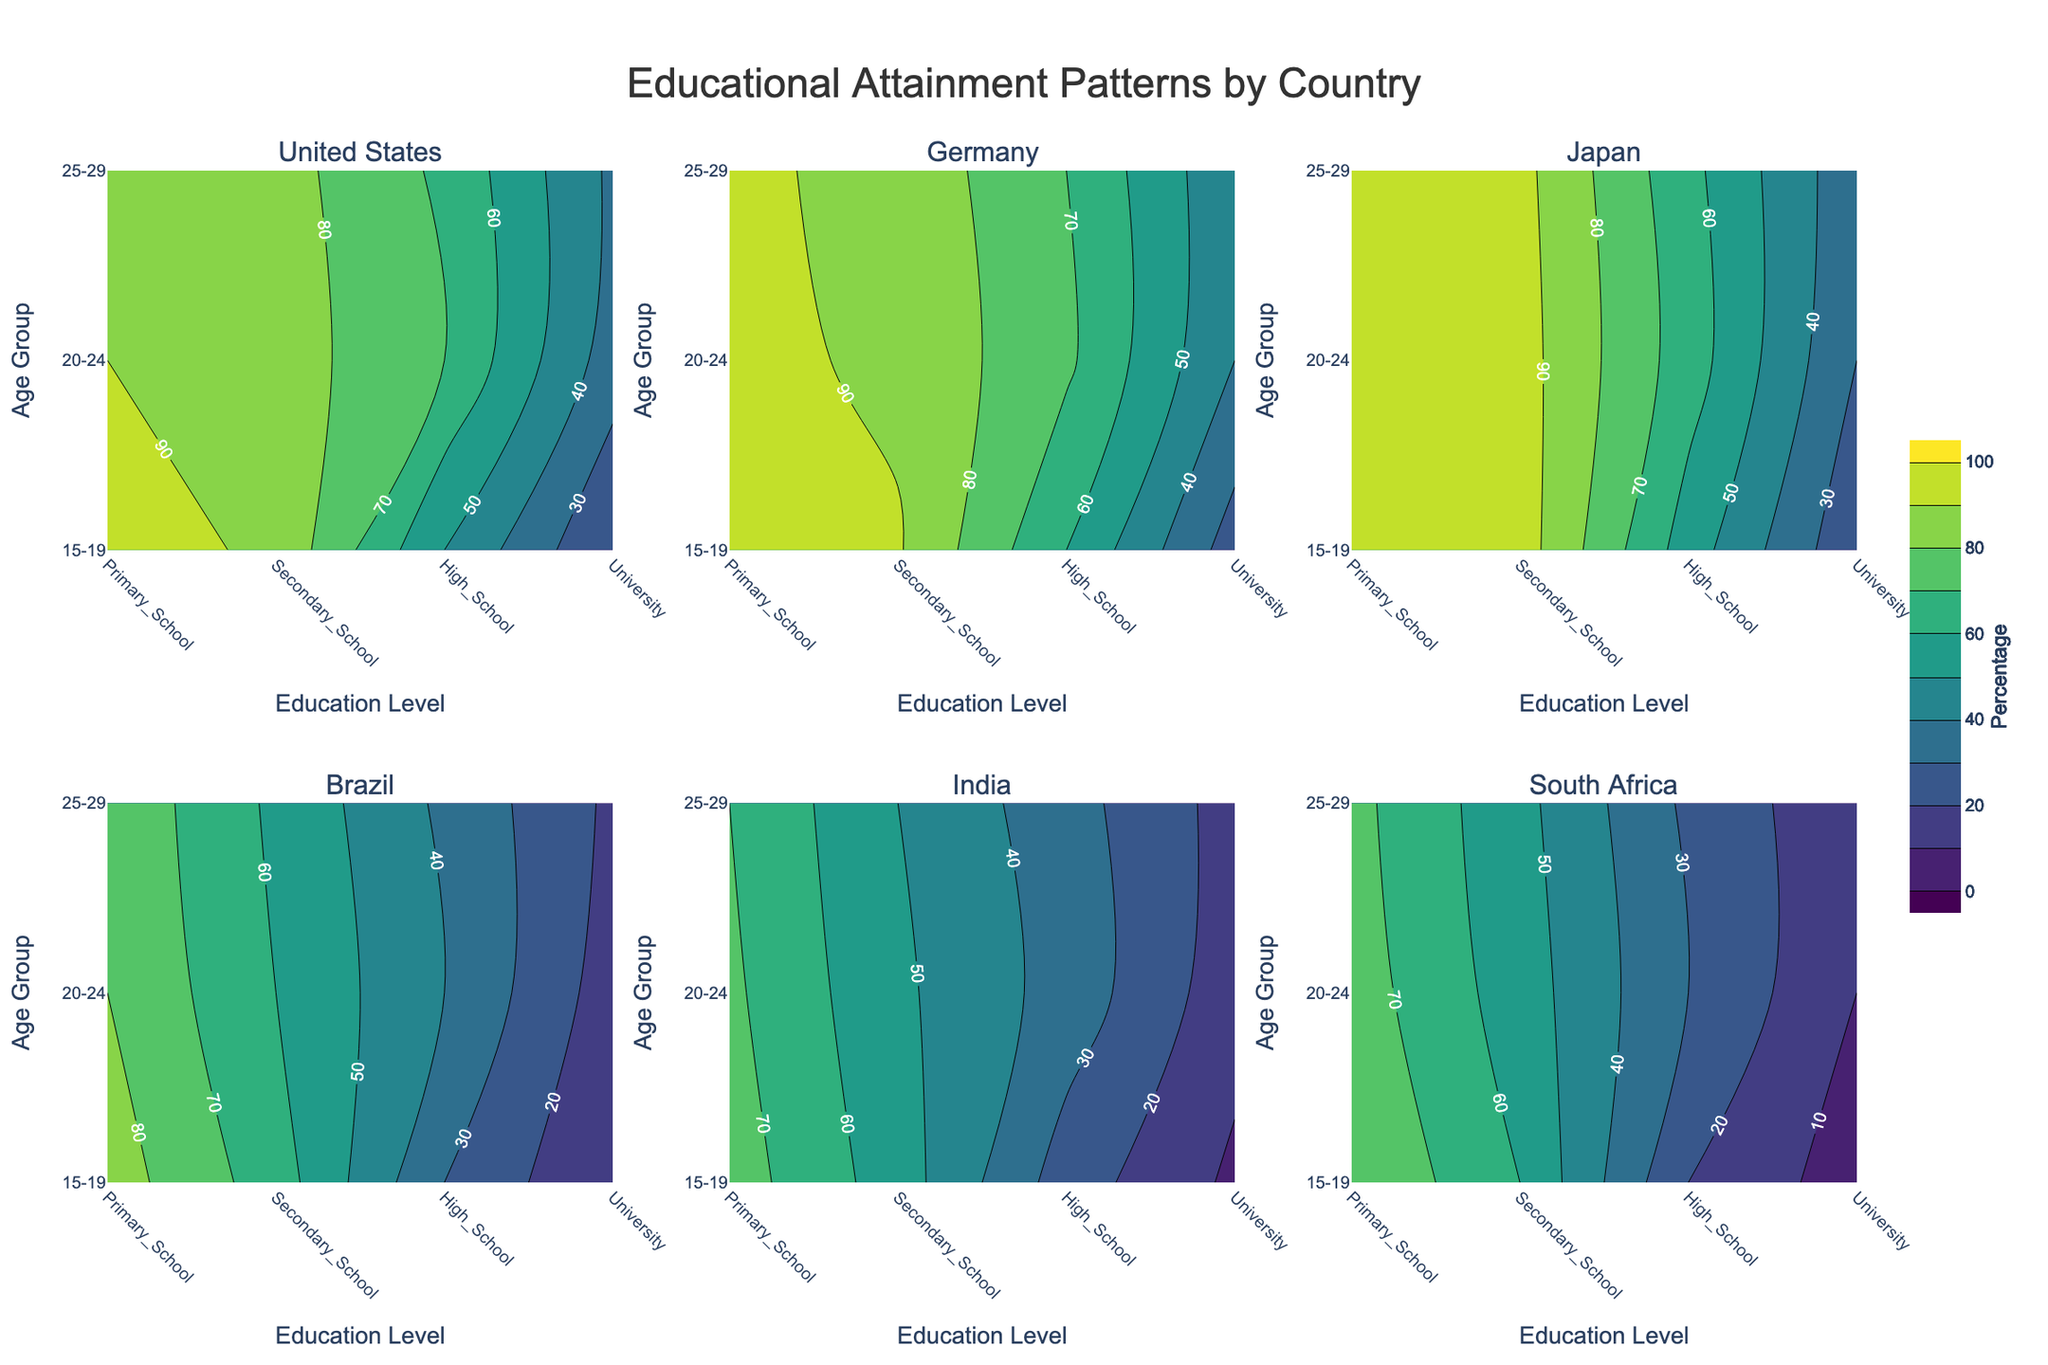What is the highest percentage for university education in Germany among the 25-29 age group? Locate the contour subplot for Germany and check the percentage value for the University level in the 25-29 age group.
Answer: 42 Which country shows the highest percentage for primary school education in the 15-19 age group? Examine the primary school percentages for the 15-19 age group across all country subplots and identify the highest value.
Answer: Japan Is the percentage of secondary school education for the 20-24 age group higher in Brazil or India? Compare the secondary school percentages for the 20-24 age group in the subplots for Brazil and India.
Answer: Brazil What are the education levels listed on the x-axis of each subplot? Observe the x-axis labels of any subplot.
Answer: Primary School, Secondary School, High School, University Which age group in the United States attains the highest percentage in secondary school education? Look at the subplot for the United States and compare the secondary school percentages across different age groups.
Answer: 15-19 How does the educational attainment for high school in Japan's 20-24 age group compare to the 25-29 age group? Inspect the high school education percentages in the 20-24 and 25-29 age groups in the subplot for Japan and compare them.
Answer: 65 vs 63 Does South Africa have a higher University education percentage for the 20-24 age group compared to the 15-19 age group? Check the University education percentages in the 20-24 and 15-19 age groups in the subplot for South Africa to see which is higher.
Answer: Yes What is the smallest percentage value depicted in the contour plot and which country does it belong to? Identify the lowest percentage across all subplots.
Answer: South Africa, University, 15-19 age group with 5% How do the primary school percentages compare between Germany and Japan for the 15-19 age group? Examine and compare the primary school percentages in the 15-19 age group in the subplots for Germany and Japan.
Answer: 98 vs 99 